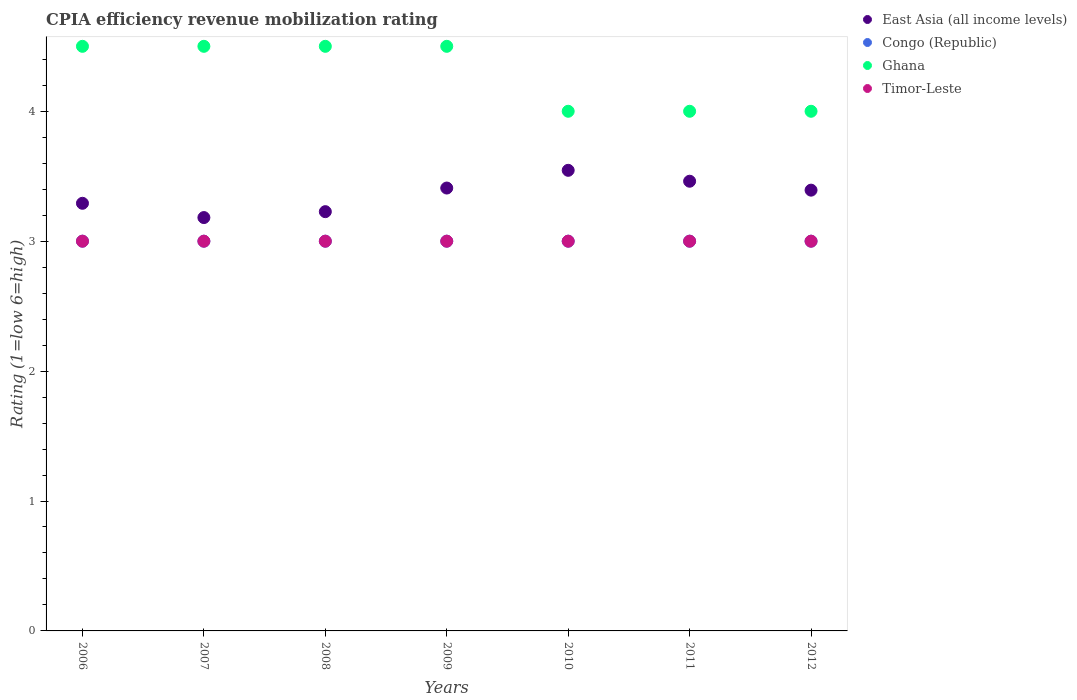Is the number of dotlines equal to the number of legend labels?
Provide a short and direct response. Yes. Across all years, what is the maximum CPIA rating in East Asia (all income levels)?
Your response must be concise. 3.55. Across all years, what is the minimum CPIA rating in Congo (Republic)?
Provide a succinct answer. 3. What is the total CPIA rating in Ghana in the graph?
Give a very brief answer. 30. What is the difference between the CPIA rating in East Asia (all income levels) in 2009 and the CPIA rating in Congo (Republic) in 2007?
Offer a terse response. 0.41. What is the average CPIA rating in Timor-Leste per year?
Ensure brevity in your answer.  3. In the year 2006, what is the difference between the CPIA rating in Timor-Leste and CPIA rating in East Asia (all income levels)?
Keep it short and to the point. -0.29. Is the CPIA rating in Ghana in 2009 less than that in 2010?
Your answer should be very brief. No. Is the difference between the CPIA rating in Timor-Leste in 2007 and 2009 greater than the difference between the CPIA rating in East Asia (all income levels) in 2007 and 2009?
Give a very brief answer. Yes. What is the difference between the highest and the second highest CPIA rating in Congo (Republic)?
Offer a terse response. 0. In how many years, is the CPIA rating in Timor-Leste greater than the average CPIA rating in Timor-Leste taken over all years?
Offer a terse response. 0. Is it the case that in every year, the sum of the CPIA rating in Timor-Leste and CPIA rating in East Asia (all income levels)  is greater than the sum of CPIA rating in Congo (Republic) and CPIA rating in Ghana?
Your response must be concise. No. Is it the case that in every year, the sum of the CPIA rating in Timor-Leste and CPIA rating in Congo (Republic)  is greater than the CPIA rating in Ghana?
Your answer should be very brief. Yes. Is the CPIA rating in Ghana strictly greater than the CPIA rating in Congo (Republic) over the years?
Your answer should be compact. Yes. Is the CPIA rating in East Asia (all income levels) strictly less than the CPIA rating in Congo (Republic) over the years?
Make the answer very short. No. How many dotlines are there?
Provide a short and direct response. 4. How many years are there in the graph?
Keep it short and to the point. 7. What is the difference between two consecutive major ticks on the Y-axis?
Keep it short and to the point. 1. Where does the legend appear in the graph?
Offer a terse response. Top right. What is the title of the graph?
Make the answer very short. CPIA efficiency revenue mobilization rating. What is the Rating (1=low 6=high) of East Asia (all income levels) in 2006?
Your answer should be compact. 3.29. What is the Rating (1=low 6=high) in Ghana in 2006?
Make the answer very short. 4.5. What is the Rating (1=low 6=high) in Timor-Leste in 2006?
Provide a succinct answer. 3. What is the Rating (1=low 6=high) in East Asia (all income levels) in 2007?
Provide a succinct answer. 3.18. What is the Rating (1=low 6=high) in Congo (Republic) in 2007?
Offer a terse response. 3. What is the Rating (1=low 6=high) of East Asia (all income levels) in 2008?
Provide a short and direct response. 3.23. What is the Rating (1=low 6=high) in Ghana in 2008?
Keep it short and to the point. 4.5. What is the Rating (1=low 6=high) of East Asia (all income levels) in 2009?
Ensure brevity in your answer.  3.41. What is the Rating (1=low 6=high) of Timor-Leste in 2009?
Make the answer very short. 3. What is the Rating (1=low 6=high) of East Asia (all income levels) in 2010?
Keep it short and to the point. 3.55. What is the Rating (1=low 6=high) in East Asia (all income levels) in 2011?
Make the answer very short. 3.46. What is the Rating (1=low 6=high) of Congo (Republic) in 2011?
Provide a short and direct response. 3. What is the Rating (1=low 6=high) of Timor-Leste in 2011?
Provide a succinct answer. 3. What is the Rating (1=low 6=high) of East Asia (all income levels) in 2012?
Provide a succinct answer. 3.39. What is the Rating (1=low 6=high) in Congo (Republic) in 2012?
Provide a short and direct response. 3. What is the Rating (1=low 6=high) of Ghana in 2012?
Keep it short and to the point. 4. Across all years, what is the maximum Rating (1=low 6=high) in East Asia (all income levels)?
Keep it short and to the point. 3.55. Across all years, what is the minimum Rating (1=low 6=high) in East Asia (all income levels)?
Give a very brief answer. 3.18. Across all years, what is the minimum Rating (1=low 6=high) of Timor-Leste?
Ensure brevity in your answer.  3. What is the total Rating (1=low 6=high) of East Asia (all income levels) in the graph?
Offer a very short reply. 23.51. What is the total Rating (1=low 6=high) in Congo (Republic) in the graph?
Provide a succinct answer. 21. What is the total Rating (1=low 6=high) in Ghana in the graph?
Give a very brief answer. 30. What is the total Rating (1=low 6=high) of Timor-Leste in the graph?
Offer a very short reply. 21. What is the difference between the Rating (1=low 6=high) of East Asia (all income levels) in 2006 and that in 2007?
Your answer should be very brief. 0.11. What is the difference between the Rating (1=low 6=high) of Congo (Republic) in 2006 and that in 2007?
Offer a terse response. 0. What is the difference between the Rating (1=low 6=high) of Timor-Leste in 2006 and that in 2007?
Your answer should be compact. 0. What is the difference between the Rating (1=low 6=high) of East Asia (all income levels) in 2006 and that in 2008?
Provide a succinct answer. 0.06. What is the difference between the Rating (1=low 6=high) in Congo (Republic) in 2006 and that in 2008?
Your answer should be very brief. 0. What is the difference between the Rating (1=low 6=high) of Ghana in 2006 and that in 2008?
Provide a succinct answer. 0. What is the difference between the Rating (1=low 6=high) of East Asia (all income levels) in 2006 and that in 2009?
Provide a succinct answer. -0.12. What is the difference between the Rating (1=low 6=high) of Ghana in 2006 and that in 2009?
Provide a succinct answer. 0. What is the difference between the Rating (1=low 6=high) of Timor-Leste in 2006 and that in 2009?
Ensure brevity in your answer.  0. What is the difference between the Rating (1=low 6=high) in East Asia (all income levels) in 2006 and that in 2010?
Your answer should be compact. -0.25. What is the difference between the Rating (1=low 6=high) of Ghana in 2006 and that in 2010?
Make the answer very short. 0.5. What is the difference between the Rating (1=low 6=high) of East Asia (all income levels) in 2006 and that in 2011?
Ensure brevity in your answer.  -0.17. What is the difference between the Rating (1=low 6=high) in Congo (Republic) in 2006 and that in 2011?
Provide a succinct answer. 0. What is the difference between the Rating (1=low 6=high) of East Asia (all income levels) in 2006 and that in 2012?
Your answer should be compact. -0.1. What is the difference between the Rating (1=low 6=high) of East Asia (all income levels) in 2007 and that in 2008?
Make the answer very short. -0.05. What is the difference between the Rating (1=low 6=high) in Timor-Leste in 2007 and that in 2008?
Provide a short and direct response. 0. What is the difference between the Rating (1=low 6=high) in East Asia (all income levels) in 2007 and that in 2009?
Your response must be concise. -0.23. What is the difference between the Rating (1=low 6=high) of Congo (Republic) in 2007 and that in 2009?
Provide a succinct answer. 0. What is the difference between the Rating (1=low 6=high) of Ghana in 2007 and that in 2009?
Your answer should be compact. 0. What is the difference between the Rating (1=low 6=high) in Timor-Leste in 2007 and that in 2009?
Offer a very short reply. 0. What is the difference between the Rating (1=low 6=high) in East Asia (all income levels) in 2007 and that in 2010?
Keep it short and to the point. -0.36. What is the difference between the Rating (1=low 6=high) of Congo (Republic) in 2007 and that in 2010?
Provide a short and direct response. 0. What is the difference between the Rating (1=low 6=high) of Timor-Leste in 2007 and that in 2010?
Your answer should be compact. 0. What is the difference between the Rating (1=low 6=high) of East Asia (all income levels) in 2007 and that in 2011?
Ensure brevity in your answer.  -0.28. What is the difference between the Rating (1=low 6=high) in Ghana in 2007 and that in 2011?
Offer a very short reply. 0.5. What is the difference between the Rating (1=low 6=high) in Timor-Leste in 2007 and that in 2011?
Your answer should be very brief. 0. What is the difference between the Rating (1=low 6=high) in East Asia (all income levels) in 2007 and that in 2012?
Your response must be concise. -0.21. What is the difference between the Rating (1=low 6=high) in Ghana in 2007 and that in 2012?
Your answer should be compact. 0.5. What is the difference between the Rating (1=low 6=high) in Timor-Leste in 2007 and that in 2012?
Offer a very short reply. 0. What is the difference between the Rating (1=low 6=high) in East Asia (all income levels) in 2008 and that in 2009?
Your answer should be very brief. -0.18. What is the difference between the Rating (1=low 6=high) in Congo (Republic) in 2008 and that in 2009?
Give a very brief answer. 0. What is the difference between the Rating (1=low 6=high) in East Asia (all income levels) in 2008 and that in 2010?
Keep it short and to the point. -0.32. What is the difference between the Rating (1=low 6=high) of Congo (Republic) in 2008 and that in 2010?
Make the answer very short. 0. What is the difference between the Rating (1=low 6=high) of Ghana in 2008 and that in 2010?
Keep it short and to the point. 0.5. What is the difference between the Rating (1=low 6=high) in East Asia (all income levels) in 2008 and that in 2011?
Keep it short and to the point. -0.23. What is the difference between the Rating (1=low 6=high) of Timor-Leste in 2008 and that in 2011?
Keep it short and to the point. 0. What is the difference between the Rating (1=low 6=high) of East Asia (all income levels) in 2008 and that in 2012?
Ensure brevity in your answer.  -0.17. What is the difference between the Rating (1=low 6=high) of Ghana in 2008 and that in 2012?
Give a very brief answer. 0.5. What is the difference between the Rating (1=low 6=high) in Timor-Leste in 2008 and that in 2012?
Your answer should be compact. 0. What is the difference between the Rating (1=low 6=high) in East Asia (all income levels) in 2009 and that in 2010?
Ensure brevity in your answer.  -0.14. What is the difference between the Rating (1=low 6=high) of Ghana in 2009 and that in 2010?
Make the answer very short. 0.5. What is the difference between the Rating (1=low 6=high) of Timor-Leste in 2009 and that in 2010?
Keep it short and to the point. 0. What is the difference between the Rating (1=low 6=high) of East Asia (all income levels) in 2009 and that in 2011?
Provide a succinct answer. -0.05. What is the difference between the Rating (1=low 6=high) of Ghana in 2009 and that in 2011?
Keep it short and to the point. 0.5. What is the difference between the Rating (1=low 6=high) of Timor-Leste in 2009 and that in 2011?
Provide a short and direct response. 0. What is the difference between the Rating (1=low 6=high) of East Asia (all income levels) in 2009 and that in 2012?
Keep it short and to the point. 0.02. What is the difference between the Rating (1=low 6=high) of Congo (Republic) in 2009 and that in 2012?
Keep it short and to the point. 0. What is the difference between the Rating (1=low 6=high) in East Asia (all income levels) in 2010 and that in 2011?
Your answer should be compact. 0.08. What is the difference between the Rating (1=low 6=high) of Congo (Republic) in 2010 and that in 2011?
Your response must be concise. 0. What is the difference between the Rating (1=low 6=high) in East Asia (all income levels) in 2010 and that in 2012?
Your answer should be very brief. 0.15. What is the difference between the Rating (1=low 6=high) of Ghana in 2010 and that in 2012?
Offer a terse response. 0. What is the difference between the Rating (1=low 6=high) in Timor-Leste in 2010 and that in 2012?
Ensure brevity in your answer.  0. What is the difference between the Rating (1=low 6=high) in East Asia (all income levels) in 2011 and that in 2012?
Offer a very short reply. 0.07. What is the difference between the Rating (1=low 6=high) in Congo (Republic) in 2011 and that in 2012?
Provide a succinct answer. 0. What is the difference between the Rating (1=low 6=high) of Ghana in 2011 and that in 2012?
Your answer should be compact. 0. What is the difference between the Rating (1=low 6=high) in Timor-Leste in 2011 and that in 2012?
Make the answer very short. 0. What is the difference between the Rating (1=low 6=high) in East Asia (all income levels) in 2006 and the Rating (1=low 6=high) in Congo (Republic) in 2007?
Your answer should be compact. 0.29. What is the difference between the Rating (1=low 6=high) of East Asia (all income levels) in 2006 and the Rating (1=low 6=high) of Ghana in 2007?
Offer a terse response. -1.21. What is the difference between the Rating (1=low 6=high) of East Asia (all income levels) in 2006 and the Rating (1=low 6=high) of Timor-Leste in 2007?
Provide a succinct answer. 0.29. What is the difference between the Rating (1=low 6=high) of Congo (Republic) in 2006 and the Rating (1=low 6=high) of Timor-Leste in 2007?
Offer a very short reply. 0. What is the difference between the Rating (1=low 6=high) in East Asia (all income levels) in 2006 and the Rating (1=low 6=high) in Congo (Republic) in 2008?
Your response must be concise. 0.29. What is the difference between the Rating (1=low 6=high) in East Asia (all income levels) in 2006 and the Rating (1=low 6=high) in Ghana in 2008?
Give a very brief answer. -1.21. What is the difference between the Rating (1=low 6=high) in East Asia (all income levels) in 2006 and the Rating (1=low 6=high) in Timor-Leste in 2008?
Make the answer very short. 0.29. What is the difference between the Rating (1=low 6=high) in Congo (Republic) in 2006 and the Rating (1=low 6=high) in Ghana in 2008?
Your answer should be compact. -1.5. What is the difference between the Rating (1=low 6=high) in Congo (Republic) in 2006 and the Rating (1=low 6=high) in Timor-Leste in 2008?
Give a very brief answer. 0. What is the difference between the Rating (1=low 6=high) in Ghana in 2006 and the Rating (1=low 6=high) in Timor-Leste in 2008?
Ensure brevity in your answer.  1.5. What is the difference between the Rating (1=low 6=high) of East Asia (all income levels) in 2006 and the Rating (1=low 6=high) of Congo (Republic) in 2009?
Ensure brevity in your answer.  0.29. What is the difference between the Rating (1=low 6=high) of East Asia (all income levels) in 2006 and the Rating (1=low 6=high) of Ghana in 2009?
Your response must be concise. -1.21. What is the difference between the Rating (1=low 6=high) of East Asia (all income levels) in 2006 and the Rating (1=low 6=high) of Timor-Leste in 2009?
Make the answer very short. 0.29. What is the difference between the Rating (1=low 6=high) of Congo (Republic) in 2006 and the Rating (1=low 6=high) of Ghana in 2009?
Provide a succinct answer. -1.5. What is the difference between the Rating (1=low 6=high) in Congo (Republic) in 2006 and the Rating (1=low 6=high) in Timor-Leste in 2009?
Keep it short and to the point. 0. What is the difference between the Rating (1=low 6=high) of Ghana in 2006 and the Rating (1=low 6=high) of Timor-Leste in 2009?
Your response must be concise. 1.5. What is the difference between the Rating (1=low 6=high) in East Asia (all income levels) in 2006 and the Rating (1=low 6=high) in Congo (Republic) in 2010?
Provide a short and direct response. 0.29. What is the difference between the Rating (1=low 6=high) in East Asia (all income levels) in 2006 and the Rating (1=low 6=high) in Ghana in 2010?
Your answer should be compact. -0.71. What is the difference between the Rating (1=low 6=high) in East Asia (all income levels) in 2006 and the Rating (1=low 6=high) in Timor-Leste in 2010?
Offer a terse response. 0.29. What is the difference between the Rating (1=low 6=high) of Congo (Republic) in 2006 and the Rating (1=low 6=high) of Timor-Leste in 2010?
Make the answer very short. 0. What is the difference between the Rating (1=low 6=high) of East Asia (all income levels) in 2006 and the Rating (1=low 6=high) of Congo (Republic) in 2011?
Your answer should be very brief. 0.29. What is the difference between the Rating (1=low 6=high) of East Asia (all income levels) in 2006 and the Rating (1=low 6=high) of Ghana in 2011?
Keep it short and to the point. -0.71. What is the difference between the Rating (1=low 6=high) in East Asia (all income levels) in 2006 and the Rating (1=low 6=high) in Timor-Leste in 2011?
Ensure brevity in your answer.  0.29. What is the difference between the Rating (1=low 6=high) in Congo (Republic) in 2006 and the Rating (1=low 6=high) in Ghana in 2011?
Make the answer very short. -1. What is the difference between the Rating (1=low 6=high) of Congo (Republic) in 2006 and the Rating (1=low 6=high) of Timor-Leste in 2011?
Make the answer very short. 0. What is the difference between the Rating (1=low 6=high) of East Asia (all income levels) in 2006 and the Rating (1=low 6=high) of Congo (Republic) in 2012?
Provide a succinct answer. 0.29. What is the difference between the Rating (1=low 6=high) of East Asia (all income levels) in 2006 and the Rating (1=low 6=high) of Ghana in 2012?
Your response must be concise. -0.71. What is the difference between the Rating (1=low 6=high) of East Asia (all income levels) in 2006 and the Rating (1=low 6=high) of Timor-Leste in 2012?
Your answer should be compact. 0.29. What is the difference between the Rating (1=low 6=high) in Congo (Republic) in 2006 and the Rating (1=low 6=high) in Ghana in 2012?
Your answer should be compact. -1. What is the difference between the Rating (1=low 6=high) in Ghana in 2006 and the Rating (1=low 6=high) in Timor-Leste in 2012?
Your answer should be very brief. 1.5. What is the difference between the Rating (1=low 6=high) in East Asia (all income levels) in 2007 and the Rating (1=low 6=high) in Congo (Republic) in 2008?
Your response must be concise. 0.18. What is the difference between the Rating (1=low 6=high) in East Asia (all income levels) in 2007 and the Rating (1=low 6=high) in Ghana in 2008?
Your response must be concise. -1.32. What is the difference between the Rating (1=low 6=high) of East Asia (all income levels) in 2007 and the Rating (1=low 6=high) of Timor-Leste in 2008?
Keep it short and to the point. 0.18. What is the difference between the Rating (1=low 6=high) in Congo (Republic) in 2007 and the Rating (1=low 6=high) in Timor-Leste in 2008?
Your answer should be very brief. 0. What is the difference between the Rating (1=low 6=high) of Ghana in 2007 and the Rating (1=low 6=high) of Timor-Leste in 2008?
Your answer should be very brief. 1.5. What is the difference between the Rating (1=low 6=high) in East Asia (all income levels) in 2007 and the Rating (1=low 6=high) in Congo (Republic) in 2009?
Ensure brevity in your answer.  0.18. What is the difference between the Rating (1=low 6=high) of East Asia (all income levels) in 2007 and the Rating (1=low 6=high) of Ghana in 2009?
Give a very brief answer. -1.32. What is the difference between the Rating (1=low 6=high) of East Asia (all income levels) in 2007 and the Rating (1=low 6=high) of Timor-Leste in 2009?
Offer a very short reply. 0.18. What is the difference between the Rating (1=low 6=high) in Congo (Republic) in 2007 and the Rating (1=low 6=high) in Ghana in 2009?
Offer a very short reply. -1.5. What is the difference between the Rating (1=low 6=high) of East Asia (all income levels) in 2007 and the Rating (1=low 6=high) of Congo (Republic) in 2010?
Give a very brief answer. 0.18. What is the difference between the Rating (1=low 6=high) in East Asia (all income levels) in 2007 and the Rating (1=low 6=high) in Ghana in 2010?
Your answer should be compact. -0.82. What is the difference between the Rating (1=low 6=high) of East Asia (all income levels) in 2007 and the Rating (1=low 6=high) of Timor-Leste in 2010?
Offer a very short reply. 0.18. What is the difference between the Rating (1=low 6=high) of Congo (Republic) in 2007 and the Rating (1=low 6=high) of Timor-Leste in 2010?
Offer a terse response. 0. What is the difference between the Rating (1=low 6=high) in Ghana in 2007 and the Rating (1=low 6=high) in Timor-Leste in 2010?
Provide a succinct answer. 1.5. What is the difference between the Rating (1=low 6=high) of East Asia (all income levels) in 2007 and the Rating (1=low 6=high) of Congo (Republic) in 2011?
Offer a terse response. 0.18. What is the difference between the Rating (1=low 6=high) in East Asia (all income levels) in 2007 and the Rating (1=low 6=high) in Ghana in 2011?
Your answer should be very brief. -0.82. What is the difference between the Rating (1=low 6=high) of East Asia (all income levels) in 2007 and the Rating (1=low 6=high) of Timor-Leste in 2011?
Offer a very short reply. 0.18. What is the difference between the Rating (1=low 6=high) of Ghana in 2007 and the Rating (1=low 6=high) of Timor-Leste in 2011?
Ensure brevity in your answer.  1.5. What is the difference between the Rating (1=low 6=high) in East Asia (all income levels) in 2007 and the Rating (1=low 6=high) in Congo (Republic) in 2012?
Make the answer very short. 0.18. What is the difference between the Rating (1=low 6=high) in East Asia (all income levels) in 2007 and the Rating (1=low 6=high) in Ghana in 2012?
Keep it short and to the point. -0.82. What is the difference between the Rating (1=low 6=high) of East Asia (all income levels) in 2007 and the Rating (1=low 6=high) of Timor-Leste in 2012?
Offer a terse response. 0.18. What is the difference between the Rating (1=low 6=high) of East Asia (all income levels) in 2008 and the Rating (1=low 6=high) of Congo (Republic) in 2009?
Ensure brevity in your answer.  0.23. What is the difference between the Rating (1=low 6=high) of East Asia (all income levels) in 2008 and the Rating (1=low 6=high) of Ghana in 2009?
Keep it short and to the point. -1.27. What is the difference between the Rating (1=low 6=high) in East Asia (all income levels) in 2008 and the Rating (1=low 6=high) in Timor-Leste in 2009?
Keep it short and to the point. 0.23. What is the difference between the Rating (1=low 6=high) in East Asia (all income levels) in 2008 and the Rating (1=low 6=high) in Congo (Republic) in 2010?
Your answer should be compact. 0.23. What is the difference between the Rating (1=low 6=high) in East Asia (all income levels) in 2008 and the Rating (1=low 6=high) in Ghana in 2010?
Offer a very short reply. -0.77. What is the difference between the Rating (1=low 6=high) of East Asia (all income levels) in 2008 and the Rating (1=low 6=high) of Timor-Leste in 2010?
Your response must be concise. 0.23. What is the difference between the Rating (1=low 6=high) of Congo (Republic) in 2008 and the Rating (1=low 6=high) of Timor-Leste in 2010?
Your answer should be very brief. 0. What is the difference between the Rating (1=low 6=high) in East Asia (all income levels) in 2008 and the Rating (1=low 6=high) in Congo (Republic) in 2011?
Offer a terse response. 0.23. What is the difference between the Rating (1=low 6=high) in East Asia (all income levels) in 2008 and the Rating (1=low 6=high) in Ghana in 2011?
Provide a succinct answer. -0.77. What is the difference between the Rating (1=low 6=high) in East Asia (all income levels) in 2008 and the Rating (1=low 6=high) in Timor-Leste in 2011?
Provide a succinct answer. 0.23. What is the difference between the Rating (1=low 6=high) of Congo (Republic) in 2008 and the Rating (1=low 6=high) of Ghana in 2011?
Your answer should be compact. -1. What is the difference between the Rating (1=low 6=high) of Ghana in 2008 and the Rating (1=low 6=high) of Timor-Leste in 2011?
Provide a short and direct response. 1.5. What is the difference between the Rating (1=low 6=high) in East Asia (all income levels) in 2008 and the Rating (1=low 6=high) in Congo (Republic) in 2012?
Your answer should be very brief. 0.23. What is the difference between the Rating (1=low 6=high) in East Asia (all income levels) in 2008 and the Rating (1=low 6=high) in Ghana in 2012?
Keep it short and to the point. -0.77. What is the difference between the Rating (1=low 6=high) in East Asia (all income levels) in 2008 and the Rating (1=low 6=high) in Timor-Leste in 2012?
Make the answer very short. 0.23. What is the difference between the Rating (1=low 6=high) in Congo (Republic) in 2008 and the Rating (1=low 6=high) in Ghana in 2012?
Offer a terse response. -1. What is the difference between the Rating (1=low 6=high) in Congo (Republic) in 2008 and the Rating (1=low 6=high) in Timor-Leste in 2012?
Provide a succinct answer. 0. What is the difference between the Rating (1=low 6=high) in Ghana in 2008 and the Rating (1=low 6=high) in Timor-Leste in 2012?
Offer a terse response. 1.5. What is the difference between the Rating (1=low 6=high) in East Asia (all income levels) in 2009 and the Rating (1=low 6=high) in Congo (Republic) in 2010?
Provide a succinct answer. 0.41. What is the difference between the Rating (1=low 6=high) of East Asia (all income levels) in 2009 and the Rating (1=low 6=high) of Ghana in 2010?
Your response must be concise. -0.59. What is the difference between the Rating (1=low 6=high) in East Asia (all income levels) in 2009 and the Rating (1=low 6=high) in Timor-Leste in 2010?
Offer a terse response. 0.41. What is the difference between the Rating (1=low 6=high) in Congo (Republic) in 2009 and the Rating (1=low 6=high) in Ghana in 2010?
Ensure brevity in your answer.  -1. What is the difference between the Rating (1=low 6=high) of East Asia (all income levels) in 2009 and the Rating (1=low 6=high) of Congo (Republic) in 2011?
Ensure brevity in your answer.  0.41. What is the difference between the Rating (1=low 6=high) in East Asia (all income levels) in 2009 and the Rating (1=low 6=high) in Ghana in 2011?
Ensure brevity in your answer.  -0.59. What is the difference between the Rating (1=low 6=high) of East Asia (all income levels) in 2009 and the Rating (1=low 6=high) of Timor-Leste in 2011?
Keep it short and to the point. 0.41. What is the difference between the Rating (1=low 6=high) in Congo (Republic) in 2009 and the Rating (1=low 6=high) in Timor-Leste in 2011?
Your answer should be very brief. 0. What is the difference between the Rating (1=low 6=high) of East Asia (all income levels) in 2009 and the Rating (1=low 6=high) of Congo (Republic) in 2012?
Provide a short and direct response. 0.41. What is the difference between the Rating (1=low 6=high) of East Asia (all income levels) in 2009 and the Rating (1=low 6=high) of Ghana in 2012?
Offer a very short reply. -0.59. What is the difference between the Rating (1=low 6=high) of East Asia (all income levels) in 2009 and the Rating (1=low 6=high) of Timor-Leste in 2012?
Your response must be concise. 0.41. What is the difference between the Rating (1=low 6=high) in Ghana in 2009 and the Rating (1=low 6=high) in Timor-Leste in 2012?
Make the answer very short. 1.5. What is the difference between the Rating (1=low 6=high) of East Asia (all income levels) in 2010 and the Rating (1=low 6=high) of Congo (Republic) in 2011?
Give a very brief answer. 0.55. What is the difference between the Rating (1=low 6=high) in East Asia (all income levels) in 2010 and the Rating (1=low 6=high) in Ghana in 2011?
Ensure brevity in your answer.  -0.45. What is the difference between the Rating (1=low 6=high) of East Asia (all income levels) in 2010 and the Rating (1=low 6=high) of Timor-Leste in 2011?
Your answer should be compact. 0.55. What is the difference between the Rating (1=low 6=high) of Congo (Republic) in 2010 and the Rating (1=low 6=high) of Ghana in 2011?
Ensure brevity in your answer.  -1. What is the difference between the Rating (1=low 6=high) of Congo (Republic) in 2010 and the Rating (1=low 6=high) of Timor-Leste in 2011?
Your answer should be compact. 0. What is the difference between the Rating (1=low 6=high) of East Asia (all income levels) in 2010 and the Rating (1=low 6=high) of Congo (Republic) in 2012?
Your answer should be compact. 0.55. What is the difference between the Rating (1=low 6=high) of East Asia (all income levels) in 2010 and the Rating (1=low 6=high) of Ghana in 2012?
Offer a very short reply. -0.45. What is the difference between the Rating (1=low 6=high) of East Asia (all income levels) in 2010 and the Rating (1=low 6=high) of Timor-Leste in 2012?
Offer a very short reply. 0.55. What is the difference between the Rating (1=low 6=high) in Congo (Republic) in 2010 and the Rating (1=low 6=high) in Ghana in 2012?
Your answer should be compact. -1. What is the difference between the Rating (1=low 6=high) in Congo (Republic) in 2010 and the Rating (1=low 6=high) in Timor-Leste in 2012?
Your answer should be very brief. 0. What is the difference between the Rating (1=low 6=high) in East Asia (all income levels) in 2011 and the Rating (1=low 6=high) in Congo (Republic) in 2012?
Your answer should be very brief. 0.46. What is the difference between the Rating (1=low 6=high) in East Asia (all income levels) in 2011 and the Rating (1=low 6=high) in Ghana in 2012?
Provide a short and direct response. -0.54. What is the difference between the Rating (1=low 6=high) in East Asia (all income levels) in 2011 and the Rating (1=low 6=high) in Timor-Leste in 2012?
Offer a very short reply. 0.46. What is the difference between the Rating (1=low 6=high) in Ghana in 2011 and the Rating (1=low 6=high) in Timor-Leste in 2012?
Give a very brief answer. 1. What is the average Rating (1=low 6=high) of East Asia (all income levels) per year?
Provide a short and direct response. 3.36. What is the average Rating (1=low 6=high) in Congo (Republic) per year?
Make the answer very short. 3. What is the average Rating (1=low 6=high) of Ghana per year?
Offer a very short reply. 4.29. What is the average Rating (1=low 6=high) of Timor-Leste per year?
Make the answer very short. 3. In the year 2006, what is the difference between the Rating (1=low 6=high) in East Asia (all income levels) and Rating (1=low 6=high) in Congo (Republic)?
Make the answer very short. 0.29. In the year 2006, what is the difference between the Rating (1=low 6=high) of East Asia (all income levels) and Rating (1=low 6=high) of Ghana?
Provide a short and direct response. -1.21. In the year 2006, what is the difference between the Rating (1=low 6=high) of East Asia (all income levels) and Rating (1=low 6=high) of Timor-Leste?
Your answer should be very brief. 0.29. In the year 2006, what is the difference between the Rating (1=low 6=high) of Congo (Republic) and Rating (1=low 6=high) of Timor-Leste?
Your answer should be very brief. 0. In the year 2006, what is the difference between the Rating (1=low 6=high) of Ghana and Rating (1=low 6=high) of Timor-Leste?
Provide a short and direct response. 1.5. In the year 2007, what is the difference between the Rating (1=low 6=high) in East Asia (all income levels) and Rating (1=low 6=high) in Congo (Republic)?
Provide a succinct answer. 0.18. In the year 2007, what is the difference between the Rating (1=low 6=high) in East Asia (all income levels) and Rating (1=low 6=high) in Ghana?
Your response must be concise. -1.32. In the year 2007, what is the difference between the Rating (1=low 6=high) in East Asia (all income levels) and Rating (1=low 6=high) in Timor-Leste?
Offer a terse response. 0.18. In the year 2007, what is the difference between the Rating (1=low 6=high) in Congo (Republic) and Rating (1=low 6=high) in Ghana?
Your answer should be very brief. -1.5. In the year 2007, what is the difference between the Rating (1=low 6=high) in Congo (Republic) and Rating (1=low 6=high) in Timor-Leste?
Ensure brevity in your answer.  0. In the year 2007, what is the difference between the Rating (1=low 6=high) of Ghana and Rating (1=low 6=high) of Timor-Leste?
Give a very brief answer. 1.5. In the year 2008, what is the difference between the Rating (1=low 6=high) of East Asia (all income levels) and Rating (1=low 6=high) of Congo (Republic)?
Provide a short and direct response. 0.23. In the year 2008, what is the difference between the Rating (1=low 6=high) in East Asia (all income levels) and Rating (1=low 6=high) in Ghana?
Ensure brevity in your answer.  -1.27. In the year 2008, what is the difference between the Rating (1=low 6=high) in East Asia (all income levels) and Rating (1=low 6=high) in Timor-Leste?
Your answer should be very brief. 0.23. In the year 2008, what is the difference between the Rating (1=low 6=high) in Congo (Republic) and Rating (1=low 6=high) in Timor-Leste?
Your answer should be compact. 0. In the year 2009, what is the difference between the Rating (1=low 6=high) of East Asia (all income levels) and Rating (1=low 6=high) of Congo (Republic)?
Offer a very short reply. 0.41. In the year 2009, what is the difference between the Rating (1=low 6=high) of East Asia (all income levels) and Rating (1=low 6=high) of Ghana?
Provide a short and direct response. -1.09. In the year 2009, what is the difference between the Rating (1=low 6=high) of East Asia (all income levels) and Rating (1=low 6=high) of Timor-Leste?
Offer a terse response. 0.41. In the year 2009, what is the difference between the Rating (1=low 6=high) in Congo (Republic) and Rating (1=low 6=high) in Ghana?
Your answer should be compact. -1.5. In the year 2009, what is the difference between the Rating (1=low 6=high) of Congo (Republic) and Rating (1=low 6=high) of Timor-Leste?
Your answer should be compact. 0. In the year 2009, what is the difference between the Rating (1=low 6=high) of Ghana and Rating (1=low 6=high) of Timor-Leste?
Keep it short and to the point. 1.5. In the year 2010, what is the difference between the Rating (1=low 6=high) in East Asia (all income levels) and Rating (1=low 6=high) in Congo (Republic)?
Give a very brief answer. 0.55. In the year 2010, what is the difference between the Rating (1=low 6=high) in East Asia (all income levels) and Rating (1=low 6=high) in Ghana?
Give a very brief answer. -0.45. In the year 2010, what is the difference between the Rating (1=low 6=high) in East Asia (all income levels) and Rating (1=low 6=high) in Timor-Leste?
Provide a short and direct response. 0.55. In the year 2010, what is the difference between the Rating (1=low 6=high) of Congo (Republic) and Rating (1=low 6=high) of Ghana?
Your response must be concise. -1. In the year 2010, what is the difference between the Rating (1=low 6=high) of Congo (Republic) and Rating (1=low 6=high) of Timor-Leste?
Offer a very short reply. 0. In the year 2011, what is the difference between the Rating (1=low 6=high) in East Asia (all income levels) and Rating (1=low 6=high) in Congo (Republic)?
Provide a succinct answer. 0.46. In the year 2011, what is the difference between the Rating (1=low 6=high) of East Asia (all income levels) and Rating (1=low 6=high) of Ghana?
Provide a short and direct response. -0.54. In the year 2011, what is the difference between the Rating (1=low 6=high) in East Asia (all income levels) and Rating (1=low 6=high) in Timor-Leste?
Make the answer very short. 0.46. In the year 2011, what is the difference between the Rating (1=low 6=high) in Ghana and Rating (1=low 6=high) in Timor-Leste?
Offer a terse response. 1. In the year 2012, what is the difference between the Rating (1=low 6=high) of East Asia (all income levels) and Rating (1=low 6=high) of Congo (Republic)?
Keep it short and to the point. 0.39. In the year 2012, what is the difference between the Rating (1=low 6=high) in East Asia (all income levels) and Rating (1=low 6=high) in Ghana?
Provide a short and direct response. -0.61. In the year 2012, what is the difference between the Rating (1=low 6=high) in East Asia (all income levels) and Rating (1=low 6=high) in Timor-Leste?
Ensure brevity in your answer.  0.39. In the year 2012, what is the difference between the Rating (1=low 6=high) of Congo (Republic) and Rating (1=low 6=high) of Ghana?
Provide a short and direct response. -1. In the year 2012, what is the difference between the Rating (1=low 6=high) in Congo (Republic) and Rating (1=low 6=high) in Timor-Leste?
Your response must be concise. 0. In the year 2012, what is the difference between the Rating (1=low 6=high) in Ghana and Rating (1=low 6=high) in Timor-Leste?
Make the answer very short. 1. What is the ratio of the Rating (1=low 6=high) in East Asia (all income levels) in 2006 to that in 2007?
Your answer should be very brief. 1.03. What is the ratio of the Rating (1=low 6=high) in Congo (Republic) in 2006 to that in 2007?
Offer a very short reply. 1. What is the ratio of the Rating (1=low 6=high) in Timor-Leste in 2006 to that in 2007?
Provide a succinct answer. 1. What is the ratio of the Rating (1=low 6=high) in Ghana in 2006 to that in 2008?
Your answer should be very brief. 1. What is the ratio of the Rating (1=low 6=high) of Timor-Leste in 2006 to that in 2008?
Provide a succinct answer. 1. What is the ratio of the Rating (1=low 6=high) in East Asia (all income levels) in 2006 to that in 2009?
Your answer should be compact. 0.97. What is the ratio of the Rating (1=low 6=high) of Timor-Leste in 2006 to that in 2009?
Offer a very short reply. 1. What is the ratio of the Rating (1=low 6=high) in East Asia (all income levels) in 2006 to that in 2010?
Keep it short and to the point. 0.93. What is the ratio of the Rating (1=low 6=high) in East Asia (all income levels) in 2006 to that in 2011?
Your answer should be very brief. 0.95. What is the ratio of the Rating (1=low 6=high) of Ghana in 2006 to that in 2011?
Ensure brevity in your answer.  1.12. What is the ratio of the Rating (1=low 6=high) of East Asia (all income levels) in 2006 to that in 2012?
Your response must be concise. 0.97. What is the ratio of the Rating (1=low 6=high) of Ghana in 2006 to that in 2012?
Make the answer very short. 1.12. What is the ratio of the Rating (1=low 6=high) of East Asia (all income levels) in 2007 to that in 2008?
Offer a very short reply. 0.99. What is the ratio of the Rating (1=low 6=high) in East Asia (all income levels) in 2007 to that in 2009?
Your answer should be very brief. 0.93. What is the ratio of the Rating (1=low 6=high) in Congo (Republic) in 2007 to that in 2009?
Provide a succinct answer. 1. What is the ratio of the Rating (1=low 6=high) in Timor-Leste in 2007 to that in 2009?
Offer a terse response. 1. What is the ratio of the Rating (1=low 6=high) in East Asia (all income levels) in 2007 to that in 2010?
Your response must be concise. 0.9. What is the ratio of the Rating (1=low 6=high) of East Asia (all income levels) in 2007 to that in 2011?
Give a very brief answer. 0.92. What is the ratio of the Rating (1=low 6=high) in Congo (Republic) in 2007 to that in 2011?
Give a very brief answer. 1. What is the ratio of the Rating (1=low 6=high) of East Asia (all income levels) in 2007 to that in 2012?
Offer a terse response. 0.94. What is the ratio of the Rating (1=low 6=high) in Ghana in 2007 to that in 2012?
Your response must be concise. 1.12. What is the ratio of the Rating (1=low 6=high) in East Asia (all income levels) in 2008 to that in 2009?
Give a very brief answer. 0.95. What is the ratio of the Rating (1=low 6=high) of Congo (Republic) in 2008 to that in 2009?
Ensure brevity in your answer.  1. What is the ratio of the Rating (1=low 6=high) in Timor-Leste in 2008 to that in 2009?
Provide a succinct answer. 1. What is the ratio of the Rating (1=low 6=high) of East Asia (all income levels) in 2008 to that in 2010?
Give a very brief answer. 0.91. What is the ratio of the Rating (1=low 6=high) of Congo (Republic) in 2008 to that in 2010?
Make the answer very short. 1. What is the ratio of the Rating (1=low 6=high) in Ghana in 2008 to that in 2010?
Your answer should be compact. 1.12. What is the ratio of the Rating (1=low 6=high) in East Asia (all income levels) in 2008 to that in 2011?
Keep it short and to the point. 0.93. What is the ratio of the Rating (1=low 6=high) of Ghana in 2008 to that in 2011?
Your answer should be compact. 1.12. What is the ratio of the Rating (1=low 6=high) of East Asia (all income levels) in 2008 to that in 2012?
Your answer should be very brief. 0.95. What is the ratio of the Rating (1=low 6=high) in Ghana in 2008 to that in 2012?
Your response must be concise. 1.12. What is the ratio of the Rating (1=low 6=high) in East Asia (all income levels) in 2009 to that in 2010?
Offer a very short reply. 0.96. What is the ratio of the Rating (1=low 6=high) in Ghana in 2009 to that in 2010?
Offer a terse response. 1.12. What is the ratio of the Rating (1=low 6=high) in Timor-Leste in 2009 to that in 2010?
Your answer should be very brief. 1. What is the ratio of the Rating (1=low 6=high) in Congo (Republic) in 2009 to that in 2011?
Make the answer very short. 1. What is the ratio of the Rating (1=low 6=high) of Ghana in 2009 to that in 2011?
Offer a terse response. 1.12. What is the ratio of the Rating (1=low 6=high) of Congo (Republic) in 2009 to that in 2012?
Provide a short and direct response. 1. What is the ratio of the Rating (1=low 6=high) of Ghana in 2009 to that in 2012?
Ensure brevity in your answer.  1.12. What is the ratio of the Rating (1=low 6=high) of East Asia (all income levels) in 2010 to that in 2011?
Your answer should be compact. 1.02. What is the ratio of the Rating (1=low 6=high) in Congo (Republic) in 2010 to that in 2011?
Offer a terse response. 1. What is the ratio of the Rating (1=low 6=high) of Ghana in 2010 to that in 2011?
Give a very brief answer. 1. What is the ratio of the Rating (1=low 6=high) in East Asia (all income levels) in 2010 to that in 2012?
Your answer should be compact. 1.04. What is the ratio of the Rating (1=low 6=high) of East Asia (all income levels) in 2011 to that in 2012?
Give a very brief answer. 1.02. What is the ratio of the Rating (1=low 6=high) in Ghana in 2011 to that in 2012?
Offer a terse response. 1. What is the difference between the highest and the second highest Rating (1=low 6=high) in East Asia (all income levels)?
Provide a short and direct response. 0.08. What is the difference between the highest and the second highest Rating (1=low 6=high) in Congo (Republic)?
Offer a very short reply. 0. What is the difference between the highest and the lowest Rating (1=low 6=high) in East Asia (all income levels)?
Offer a terse response. 0.36. What is the difference between the highest and the lowest Rating (1=low 6=high) of Timor-Leste?
Give a very brief answer. 0. 